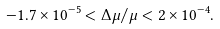<formula> <loc_0><loc_0><loc_500><loc_500>- 1 . 7 \times 1 0 ^ { - 5 } < \Delta \mu / \mu < 2 \times 1 0 ^ { - 4 } .</formula> 